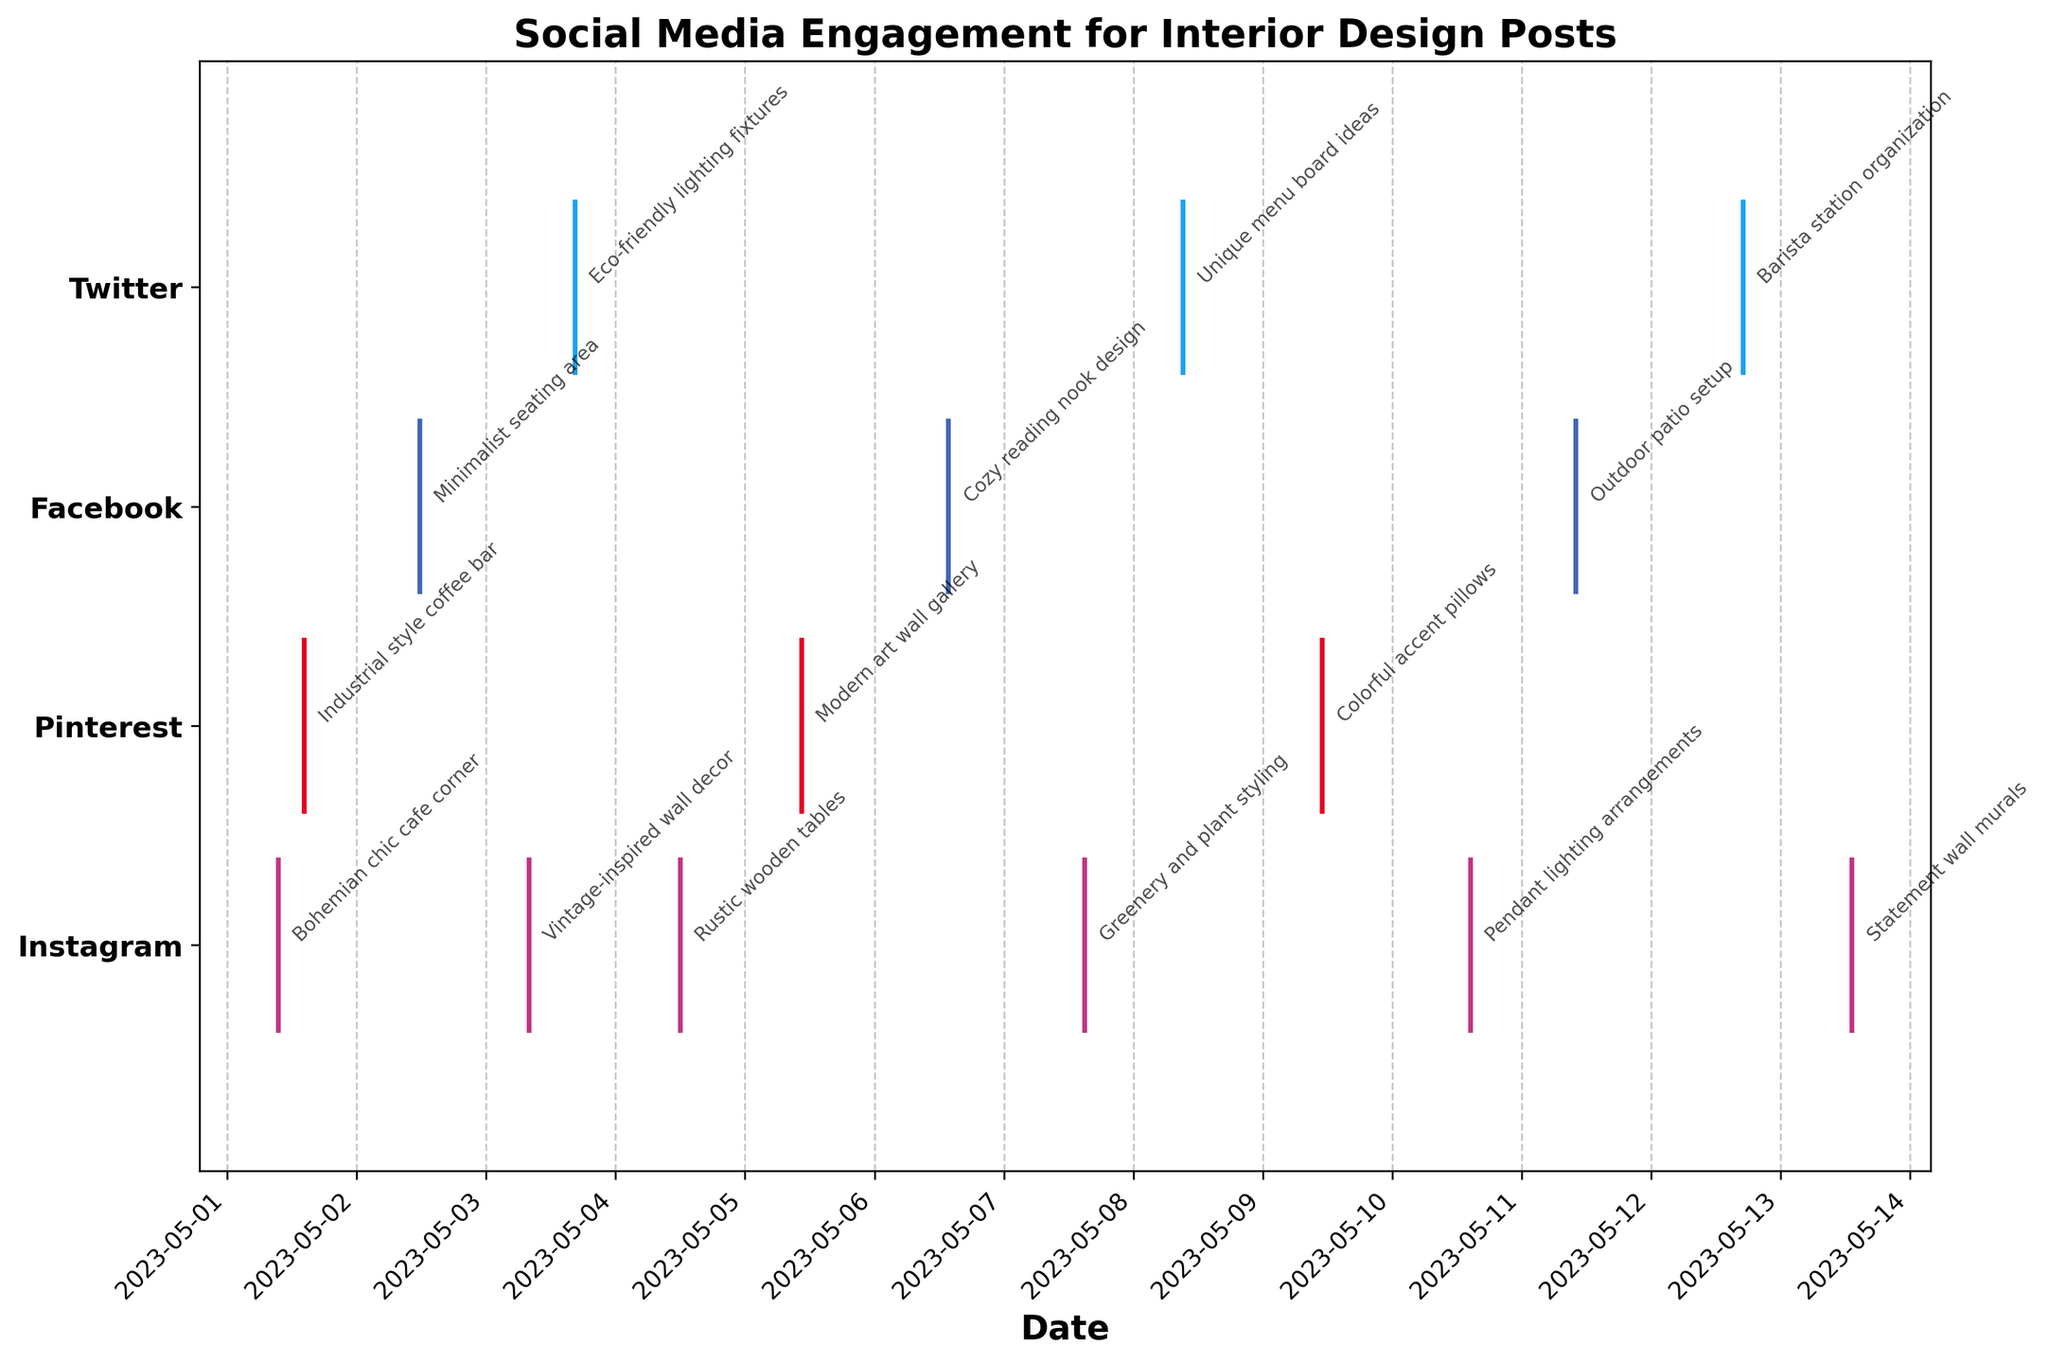What is the title of the plot? The title is displayed at the top of the plot. It helps to understand the main subject of the plot.
Answer: Social Media Engagement for Interior Design Posts How many platforms are represented in the plot? By looking at the y-axis, we can count the number of unique platforms listed.
Answer: 4 Which platform has the earliest engagement timestamp? By identifying the leftmost data point on the plot, we can determine the platform with the earliest timestamp.
Answer: Instagram How many engagement timestamps are shown for Pinterest? By counting the number of data points vertically aligned with Pinterest on the plot, we can determine the number of engagement timestamps.
Answer: 3 What is the approximate time difference between the first Twitter post and the last Facebook post? Find the timestamps of the first Twitter post and the last Facebook post on the x-axis, and calculate the difference between these two dates.
Answer: 9 days, 5 hours, and 15 minutes Which platform has the most engagement timestamps? By counting the number of data points for each platform and comparing, we can find the platform with the most engagements.
Answer: Instagram Are there more engagements in the morning or afternoon for Instagram? By examining the time-of-day portion of the Instagram data points, we can compare the number of engagements in the morning (before 12:00 PM) to those in the afternoon (after 12:00 PM).
Answer: Morning What type of posts are engaged with on Facebook? By observing the annotations aligned with Facebook's data points, we can list the types of posts associated with that platform.
Answer: Minimalist seating area, Cozy reading nook design, Outdoor patio setup Which platform has the latest engagement timestamp? By identifying the rightmost data point on the plot, we can determine the platform with the latest timestamp.
Answer: Twitter Is there any overlap between the engagement times of Instagram and Pinterest posts? By visually comparing the timestamps of Instagram and Pinterest, we can determine if there are any engagement times that coincide or overlap.
Answer: No overlap 